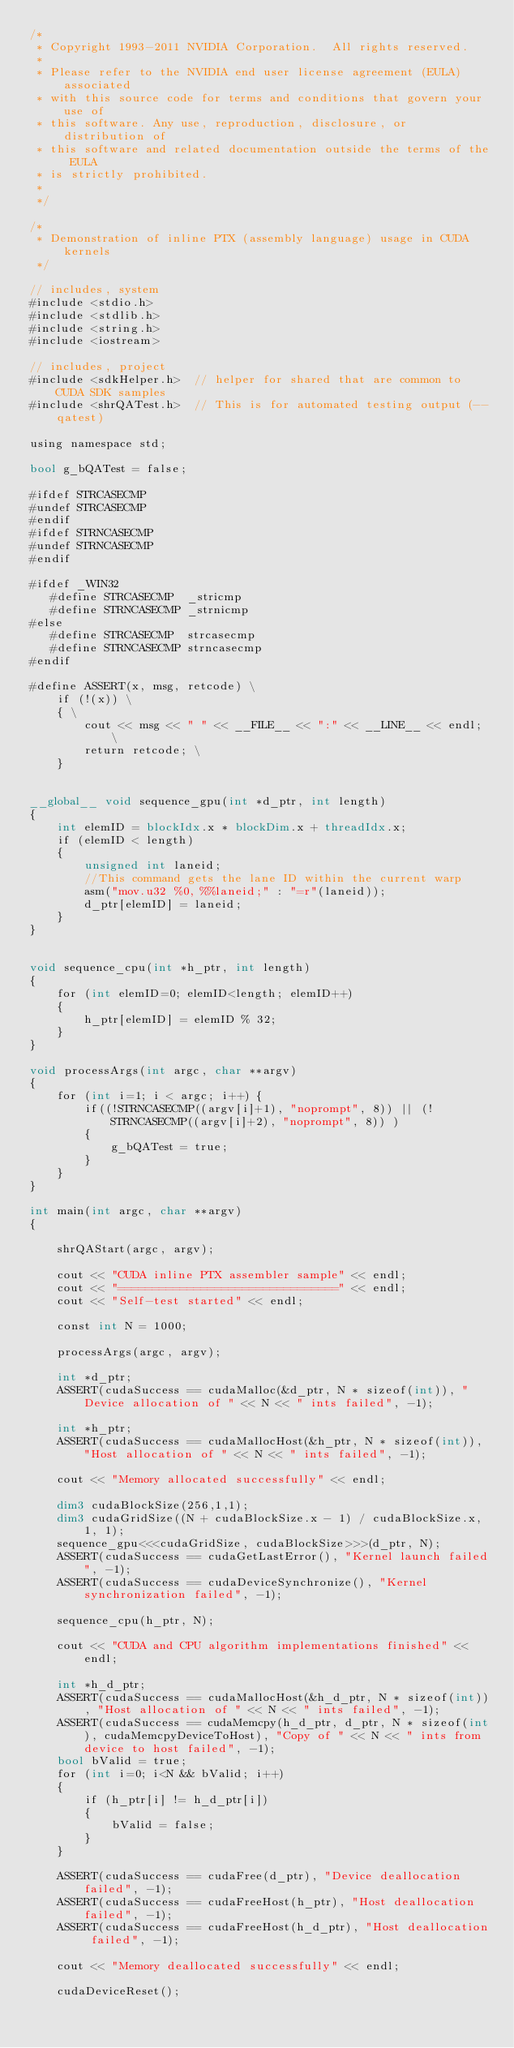Convert code to text. <code><loc_0><loc_0><loc_500><loc_500><_Cuda_>/*
 * Copyright 1993-2011 NVIDIA Corporation.  All rights reserved.
 *
 * Please refer to the NVIDIA end user license agreement (EULA) associated
 * with this source code for terms and conditions that govern your use of
 * this software. Any use, reproduction, disclosure, or distribution of
 * this software and related documentation outside the terms of the EULA
 * is strictly prohibited.
 *
 */

/*
 * Demonstration of inline PTX (assembly language) usage in CUDA kernels
 */

// includes, system
#include <stdio.h>
#include <stdlib.h>
#include <string.h>
#include <iostream>

// includes, project
#include <sdkHelper.h>  // helper for shared that are common to CUDA SDK samples
#include <shrQATest.h>  // This is for automated testing output (--qatest)

using namespace std;

bool g_bQATest = false;

#ifdef STRCASECMP
#undef STRCASECMP
#endif
#ifdef STRNCASECMP
#undef STRNCASECMP
#endif

#ifdef _WIN32
   #define STRCASECMP  _stricmp
   #define STRNCASECMP _strnicmp
#else
   #define STRCASECMP  strcasecmp
   #define STRNCASECMP strncasecmp
#endif

#define ASSERT(x, msg, retcode) \
    if (!(x)) \
    { \
        cout << msg << " " << __FILE__ << ":" << __LINE__ << endl; \
        return retcode; \
    }


__global__ void sequence_gpu(int *d_ptr, int length)
{
    int elemID = blockIdx.x * blockDim.x + threadIdx.x;
    if (elemID < length)
    {
        unsigned int laneid;
        //This command gets the lane ID within the current warp
        asm("mov.u32 %0, %%laneid;" : "=r"(laneid));
        d_ptr[elemID] = laneid;
    }
}


void sequence_cpu(int *h_ptr, int length)
{
    for (int elemID=0; elemID<length; elemID++)
    {
        h_ptr[elemID] = elemID % 32;
    }
}

void processArgs(int argc, char **argv)
{
    for (int i=1; i < argc; i++) {
        if((!STRNCASECMP((argv[i]+1), "noprompt", 8)) || (!STRNCASECMP((argv[i]+2), "noprompt", 8)) )
        {
            g_bQATest = true;
        }
    }
}

int main(int argc, char **argv)
{

    shrQAStart(argc, argv);

    cout << "CUDA inline PTX assembler sample" << endl;
    cout << "================================" << endl;
    cout << "Self-test started" << endl;

    const int N = 1000;

    processArgs(argc, argv);
    
    int *d_ptr;
    ASSERT(cudaSuccess == cudaMalloc(&d_ptr, N * sizeof(int)), "Device allocation of " << N << " ints failed", -1);

    int *h_ptr;
    ASSERT(cudaSuccess == cudaMallocHost(&h_ptr, N * sizeof(int)), "Host allocation of " << N << " ints failed", -1);

    cout << "Memory allocated successfully" << endl;

    dim3 cudaBlockSize(256,1,1);
    dim3 cudaGridSize((N + cudaBlockSize.x - 1) / cudaBlockSize.x, 1, 1);
    sequence_gpu<<<cudaGridSize, cudaBlockSize>>>(d_ptr, N);
    ASSERT(cudaSuccess == cudaGetLastError(), "Kernel launch failed", -1);
    ASSERT(cudaSuccess == cudaDeviceSynchronize(), "Kernel synchronization failed", -1);

    sequence_cpu(h_ptr, N);

    cout << "CUDA and CPU algorithm implementations finished" << endl;

    int *h_d_ptr;
    ASSERT(cudaSuccess == cudaMallocHost(&h_d_ptr, N * sizeof(int)), "Host allocation of " << N << " ints failed", -1);
    ASSERT(cudaSuccess == cudaMemcpy(h_d_ptr, d_ptr, N * sizeof(int), cudaMemcpyDeviceToHost), "Copy of " << N << " ints from device to host failed", -1);
    bool bValid = true;
    for (int i=0; i<N && bValid; i++)
    {
        if (h_ptr[i] != h_d_ptr[i])
        {
            bValid = false;
        }
    }

    ASSERT(cudaSuccess == cudaFree(d_ptr), "Device deallocation failed", -1);
    ASSERT(cudaSuccess == cudaFreeHost(h_ptr), "Host deallocation failed", -1);
    ASSERT(cudaSuccess == cudaFreeHost(h_d_ptr), "Host deallocation failed", -1);

    cout << "Memory deallocated successfully" << endl;
    
    cudaDeviceReset();
</code> 